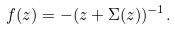<formula> <loc_0><loc_0><loc_500><loc_500>f ( z ) = - ( z + \Sigma ( z ) ) ^ { - 1 } .</formula> 